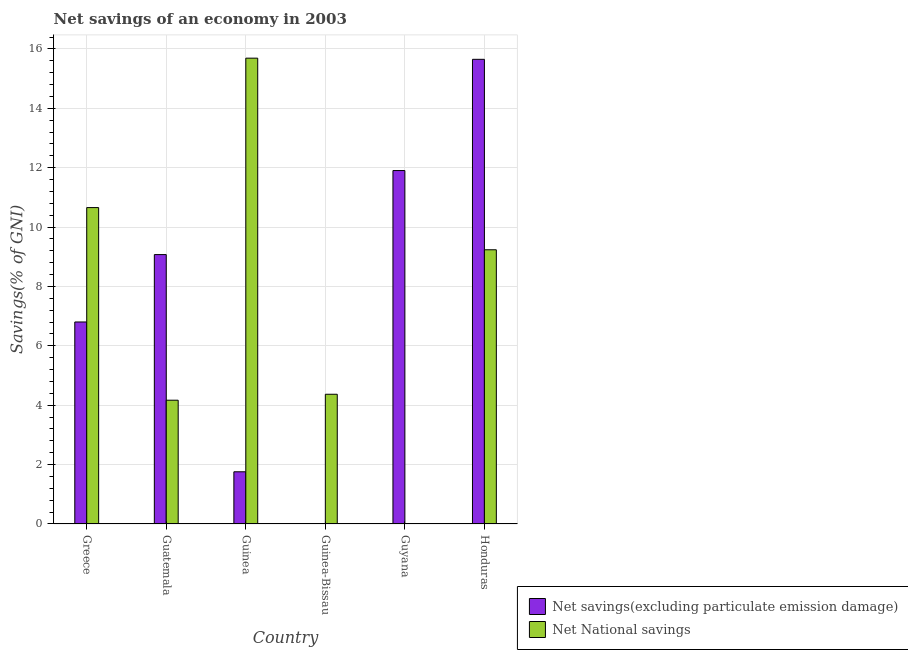How many different coloured bars are there?
Keep it short and to the point. 2. Are the number of bars per tick equal to the number of legend labels?
Ensure brevity in your answer.  No. What is the label of the 1st group of bars from the left?
Your answer should be very brief. Greece. In how many cases, is the number of bars for a given country not equal to the number of legend labels?
Your answer should be very brief. 2. What is the net national savings in Guatemala?
Your answer should be very brief. 4.17. Across all countries, what is the maximum net national savings?
Provide a short and direct response. 15.69. In which country was the net national savings maximum?
Your answer should be compact. Guinea. What is the total net national savings in the graph?
Your response must be concise. 44.12. What is the difference between the net savings(excluding particulate emission damage) in Guatemala and that in Guyana?
Your answer should be compact. -2.83. What is the difference between the net national savings in Honduras and the net savings(excluding particulate emission damage) in Guinea?
Offer a terse response. 7.48. What is the average net national savings per country?
Provide a short and direct response. 7.35. What is the difference between the net savings(excluding particulate emission damage) and net national savings in Guatemala?
Provide a succinct answer. 4.9. What is the ratio of the net national savings in Guatemala to that in Guinea-Bissau?
Give a very brief answer. 0.95. Is the net savings(excluding particulate emission damage) in Greece less than that in Guatemala?
Offer a terse response. Yes. What is the difference between the highest and the second highest net national savings?
Keep it short and to the point. 5.03. What is the difference between the highest and the lowest net national savings?
Keep it short and to the point. 15.69. How many countries are there in the graph?
Your answer should be compact. 6. Does the graph contain any zero values?
Give a very brief answer. Yes. Where does the legend appear in the graph?
Ensure brevity in your answer.  Bottom right. How many legend labels are there?
Ensure brevity in your answer.  2. How are the legend labels stacked?
Give a very brief answer. Vertical. What is the title of the graph?
Your answer should be compact. Net savings of an economy in 2003. Does "Lower secondary rate" appear as one of the legend labels in the graph?
Offer a very short reply. No. What is the label or title of the Y-axis?
Offer a very short reply. Savings(% of GNI). What is the Savings(% of GNI) of Net savings(excluding particulate emission damage) in Greece?
Your answer should be very brief. 6.8. What is the Savings(% of GNI) of Net National savings in Greece?
Offer a terse response. 10.66. What is the Savings(% of GNI) of Net savings(excluding particulate emission damage) in Guatemala?
Ensure brevity in your answer.  9.07. What is the Savings(% of GNI) of Net National savings in Guatemala?
Keep it short and to the point. 4.17. What is the Savings(% of GNI) in Net savings(excluding particulate emission damage) in Guinea?
Ensure brevity in your answer.  1.76. What is the Savings(% of GNI) in Net National savings in Guinea?
Offer a terse response. 15.69. What is the Savings(% of GNI) of Net National savings in Guinea-Bissau?
Offer a very short reply. 4.37. What is the Savings(% of GNI) in Net savings(excluding particulate emission damage) in Guyana?
Ensure brevity in your answer.  11.9. What is the Savings(% of GNI) in Net savings(excluding particulate emission damage) in Honduras?
Your answer should be compact. 15.65. What is the Savings(% of GNI) of Net National savings in Honduras?
Keep it short and to the point. 9.24. Across all countries, what is the maximum Savings(% of GNI) in Net savings(excluding particulate emission damage)?
Your answer should be very brief. 15.65. Across all countries, what is the maximum Savings(% of GNI) of Net National savings?
Provide a succinct answer. 15.69. Across all countries, what is the minimum Savings(% of GNI) of Net National savings?
Keep it short and to the point. 0. What is the total Savings(% of GNI) of Net savings(excluding particulate emission damage) in the graph?
Give a very brief answer. 45.19. What is the total Savings(% of GNI) of Net National savings in the graph?
Your response must be concise. 44.12. What is the difference between the Savings(% of GNI) in Net savings(excluding particulate emission damage) in Greece and that in Guatemala?
Your answer should be very brief. -2.27. What is the difference between the Savings(% of GNI) of Net National savings in Greece and that in Guatemala?
Offer a terse response. 6.49. What is the difference between the Savings(% of GNI) of Net savings(excluding particulate emission damage) in Greece and that in Guinea?
Ensure brevity in your answer.  5.05. What is the difference between the Savings(% of GNI) of Net National savings in Greece and that in Guinea?
Provide a succinct answer. -5.03. What is the difference between the Savings(% of GNI) of Net National savings in Greece and that in Guinea-Bissau?
Your answer should be compact. 6.29. What is the difference between the Savings(% of GNI) of Net savings(excluding particulate emission damage) in Greece and that in Guyana?
Provide a short and direct response. -5.1. What is the difference between the Savings(% of GNI) of Net savings(excluding particulate emission damage) in Greece and that in Honduras?
Your response must be concise. -8.85. What is the difference between the Savings(% of GNI) in Net National savings in Greece and that in Honduras?
Give a very brief answer. 1.42. What is the difference between the Savings(% of GNI) in Net savings(excluding particulate emission damage) in Guatemala and that in Guinea?
Give a very brief answer. 7.32. What is the difference between the Savings(% of GNI) of Net National savings in Guatemala and that in Guinea?
Provide a succinct answer. -11.52. What is the difference between the Savings(% of GNI) in Net National savings in Guatemala and that in Guinea-Bissau?
Your answer should be very brief. -0.2. What is the difference between the Savings(% of GNI) in Net savings(excluding particulate emission damage) in Guatemala and that in Guyana?
Ensure brevity in your answer.  -2.83. What is the difference between the Savings(% of GNI) in Net savings(excluding particulate emission damage) in Guatemala and that in Honduras?
Make the answer very short. -6.58. What is the difference between the Savings(% of GNI) in Net National savings in Guatemala and that in Honduras?
Offer a very short reply. -5.07. What is the difference between the Savings(% of GNI) of Net National savings in Guinea and that in Guinea-Bissau?
Your answer should be very brief. 11.32. What is the difference between the Savings(% of GNI) in Net savings(excluding particulate emission damage) in Guinea and that in Guyana?
Make the answer very short. -10.15. What is the difference between the Savings(% of GNI) in Net savings(excluding particulate emission damage) in Guinea and that in Honduras?
Offer a terse response. -13.89. What is the difference between the Savings(% of GNI) in Net National savings in Guinea and that in Honduras?
Your answer should be compact. 6.45. What is the difference between the Savings(% of GNI) of Net National savings in Guinea-Bissau and that in Honduras?
Ensure brevity in your answer.  -4.87. What is the difference between the Savings(% of GNI) of Net savings(excluding particulate emission damage) in Guyana and that in Honduras?
Give a very brief answer. -3.75. What is the difference between the Savings(% of GNI) in Net savings(excluding particulate emission damage) in Greece and the Savings(% of GNI) in Net National savings in Guatemala?
Offer a terse response. 2.63. What is the difference between the Savings(% of GNI) of Net savings(excluding particulate emission damage) in Greece and the Savings(% of GNI) of Net National savings in Guinea?
Provide a short and direct response. -8.89. What is the difference between the Savings(% of GNI) of Net savings(excluding particulate emission damage) in Greece and the Savings(% of GNI) of Net National savings in Guinea-Bissau?
Your answer should be very brief. 2.43. What is the difference between the Savings(% of GNI) in Net savings(excluding particulate emission damage) in Greece and the Savings(% of GNI) in Net National savings in Honduras?
Offer a terse response. -2.43. What is the difference between the Savings(% of GNI) in Net savings(excluding particulate emission damage) in Guatemala and the Savings(% of GNI) in Net National savings in Guinea?
Ensure brevity in your answer.  -6.62. What is the difference between the Savings(% of GNI) of Net savings(excluding particulate emission damage) in Guatemala and the Savings(% of GNI) of Net National savings in Guinea-Bissau?
Provide a short and direct response. 4.7. What is the difference between the Savings(% of GNI) of Net savings(excluding particulate emission damage) in Guatemala and the Savings(% of GNI) of Net National savings in Honduras?
Make the answer very short. -0.16. What is the difference between the Savings(% of GNI) of Net savings(excluding particulate emission damage) in Guinea and the Savings(% of GNI) of Net National savings in Guinea-Bissau?
Your response must be concise. -2.61. What is the difference between the Savings(% of GNI) of Net savings(excluding particulate emission damage) in Guinea and the Savings(% of GNI) of Net National savings in Honduras?
Provide a succinct answer. -7.48. What is the difference between the Savings(% of GNI) of Net savings(excluding particulate emission damage) in Guyana and the Savings(% of GNI) of Net National savings in Honduras?
Your answer should be very brief. 2.67. What is the average Savings(% of GNI) in Net savings(excluding particulate emission damage) per country?
Offer a terse response. 7.53. What is the average Savings(% of GNI) in Net National savings per country?
Make the answer very short. 7.35. What is the difference between the Savings(% of GNI) of Net savings(excluding particulate emission damage) and Savings(% of GNI) of Net National savings in Greece?
Provide a short and direct response. -3.85. What is the difference between the Savings(% of GNI) of Net savings(excluding particulate emission damage) and Savings(% of GNI) of Net National savings in Guatemala?
Ensure brevity in your answer.  4.9. What is the difference between the Savings(% of GNI) of Net savings(excluding particulate emission damage) and Savings(% of GNI) of Net National savings in Guinea?
Keep it short and to the point. -13.93. What is the difference between the Savings(% of GNI) of Net savings(excluding particulate emission damage) and Savings(% of GNI) of Net National savings in Honduras?
Offer a very short reply. 6.41. What is the ratio of the Savings(% of GNI) of Net savings(excluding particulate emission damage) in Greece to that in Guatemala?
Provide a succinct answer. 0.75. What is the ratio of the Savings(% of GNI) of Net National savings in Greece to that in Guatemala?
Your answer should be compact. 2.56. What is the ratio of the Savings(% of GNI) in Net savings(excluding particulate emission damage) in Greece to that in Guinea?
Provide a short and direct response. 3.87. What is the ratio of the Savings(% of GNI) of Net National savings in Greece to that in Guinea?
Offer a very short reply. 0.68. What is the ratio of the Savings(% of GNI) of Net National savings in Greece to that in Guinea-Bissau?
Provide a short and direct response. 2.44. What is the ratio of the Savings(% of GNI) in Net savings(excluding particulate emission damage) in Greece to that in Guyana?
Give a very brief answer. 0.57. What is the ratio of the Savings(% of GNI) of Net savings(excluding particulate emission damage) in Greece to that in Honduras?
Offer a terse response. 0.43. What is the ratio of the Savings(% of GNI) of Net National savings in Greece to that in Honduras?
Provide a short and direct response. 1.15. What is the ratio of the Savings(% of GNI) of Net savings(excluding particulate emission damage) in Guatemala to that in Guinea?
Your answer should be very brief. 5.16. What is the ratio of the Savings(% of GNI) of Net National savings in Guatemala to that in Guinea?
Provide a succinct answer. 0.27. What is the ratio of the Savings(% of GNI) in Net National savings in Guatemala to that in Guinea-Bissau?
Offer a very short reply. 0.95. What is the ratio of the Savings(% of GNI) of Net savings(excluding particulate emission damage) in Guatemala to that in Guyana?
Offer a terse response. 0.76. What is the ratio of the Savings(% of GNI) in Net savings(excluding particulate emission damage) in Guatemala to that in Honduras?
Give a very brief answer. 0.58. What is the ratio of the Savings(% of GNI) of Net National savings in Guatemala to that in Honduras?
Keep it short and to the point. 0.45. What is the ratio of the Savings(% of GNI) of Net National savings in Guinea to that in Guinea-Bissau?
Make the answer very short. 3.59. What is the ratio of the Savings(% of GNI) in Net savings(excluding particulate emission damage) in Guinea to that in Guyana?
Provide a short and direct response. 0.15. What is the ratio of the Savings(% of GNI) of Net savings(excluding particulate emission damage) in Guinea to that in Honduras?
Make the answer very short. 0.11. What is the ratio of the Savings(% of GNI) of Net National savings in Guinea to that in Honduras?
Offer a very short reply. 1.7. What is the ratio of the Savings(% of GNI) of Net National savings in Guinea-Bissau to that in Honduras?
Ensure brevity in your answer.  0.47. What is the ratio of the Savings(% of GNI) in Net savings(excluding particulate emission damage) in Guyana to that in Honduras?
Provide a succinct answer. 0.76. What is the difference between the highest and the second highest Savings(% of GNI) of Net savings(excluding particulate emission damage)?
Your answer should be very brief. 3.75. What is the difference between the highest and the second highest Savings(% of GNI) of Net National savings?
Offer a terse response. 5.03. What is the difference between the highest and the lowest Savings(% of GNI) of Net savings(excluding particulate emission damage)?
Your answer should be compact. 15.65. What is the difference between the highest and the lowest Savings(% of GNI) in Net National savings?
Your answer should be very brief. 15.69. 